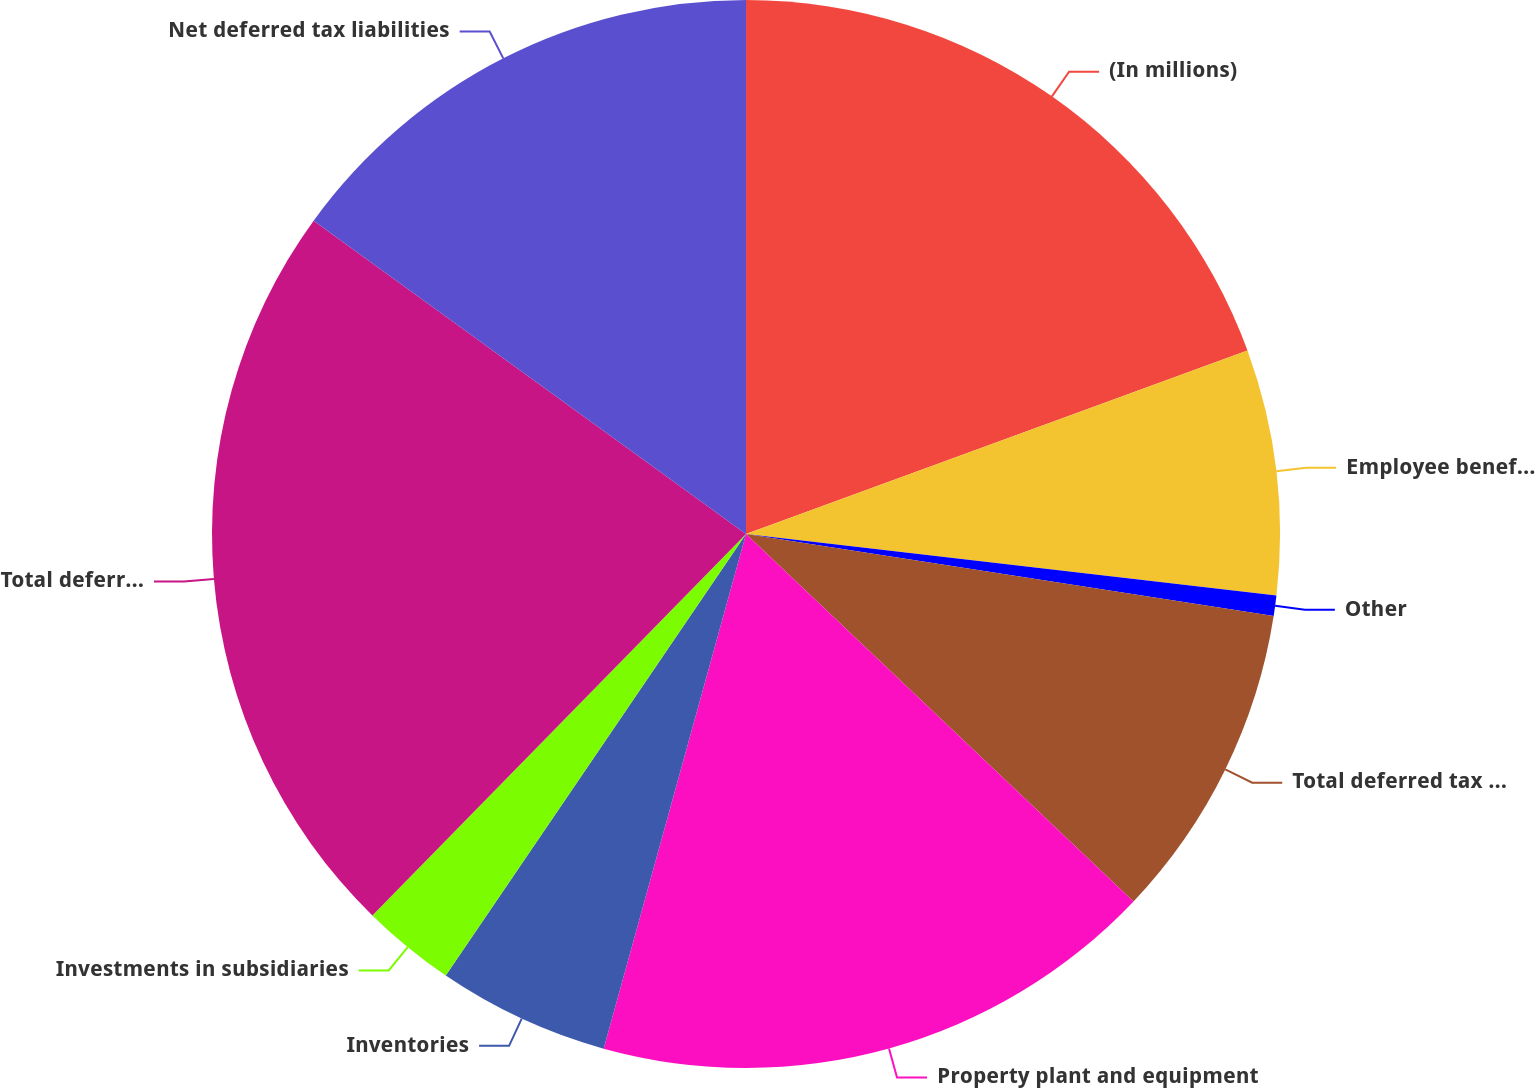<chart> <loc_0><loc_0><loc_500><loc_500><pie_chart><fcel>(In millions)<fcel>Employee benefits<fcel>Other<fcel>Total deferred tax assets<fcel>Property plant and equipment<fcel>Inventories<fcel>Investments in subsidiaries<fcel>Total deferred tax liabilities<fcel>Net deferred tax liabilities<nl><fcel>19.42%<fcel>7.42%<fcel>0.62%<fcel>9.62%<fcel>17.22%<fcel>5.21%<fcel>2.83%<fcel>22.65%<fcel>15.02%<nl></chart> 